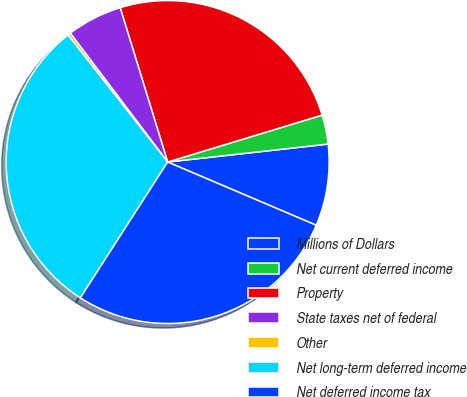Convert chart to OTSL. <chart><loc_0><loc_0><loc_500><loc_500><pie_chart><fcel>Millions of Dollars<fcel>Net current deferred income<fcel>Property<fcel>State taxes net of federal<fcel>Other<fcel>Net long-term deferred income<fcel>Net deferred income tax<nl><fcel>8.18%<fcel>2.92%<fcel>25.06%<fcel>5.55%<fcel>0.29%<fcel>30.32%<fcel>27.69%<nl></chart> 